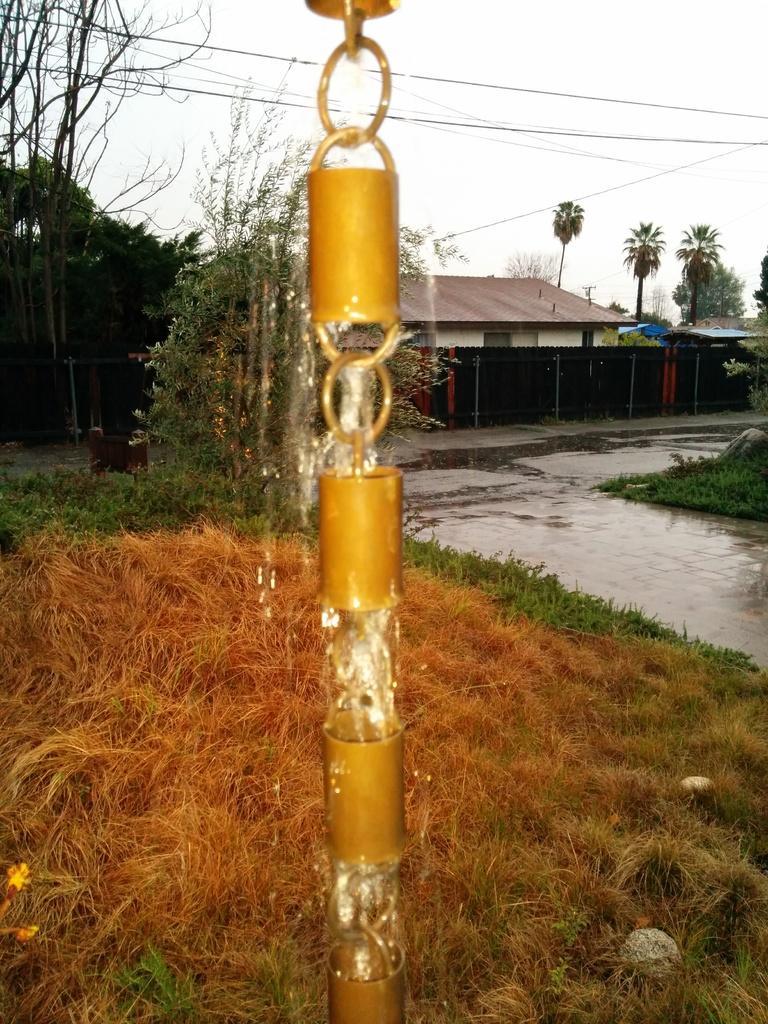Can you describe this image briefly? This image consists of a chain and we can see the water. At the bottom, there is dry grass. In the background, there are trees and houses. On the right, there is a road and we can see the water on the road. 